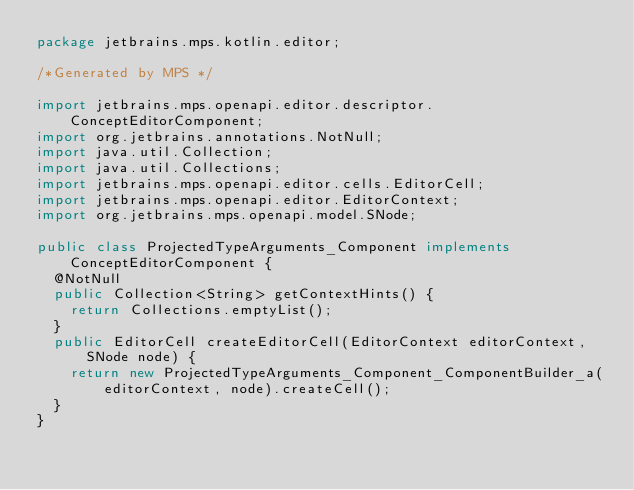<code> <loc_0><loc_0><loc_500><loc_500><_Java_>package jetbrains.mps.kotlin.editor;

/*Generated by MPS */

import jetbrains.mps.openapi.editor.descriptor.ConceptEditorComponent;
import org.jetbrains.annotations.NotNull;
import java.util.Collection;
import java.util.Collections;
import jetbrains.mps.openapi.editor.cells.EditorCell;
import jetbrains.mps.openapi.editor.EditorContext;
import org.jetbrains.mps.openapi.model.SNode;

public class ProjectedTypeArguments_Component implements ConceptEditorComponent {
  @NotNull
  public Collection<String> getContextHints() {
    return Collections.emptyList();
  }
  public EditorCell createEditorCell(EditorContext editorContext, SNode node) {
    return new ProjectedTypeArguments_Component_ComponentBuilder_a(editorContext, node).createCell();
  }
}
</code> 